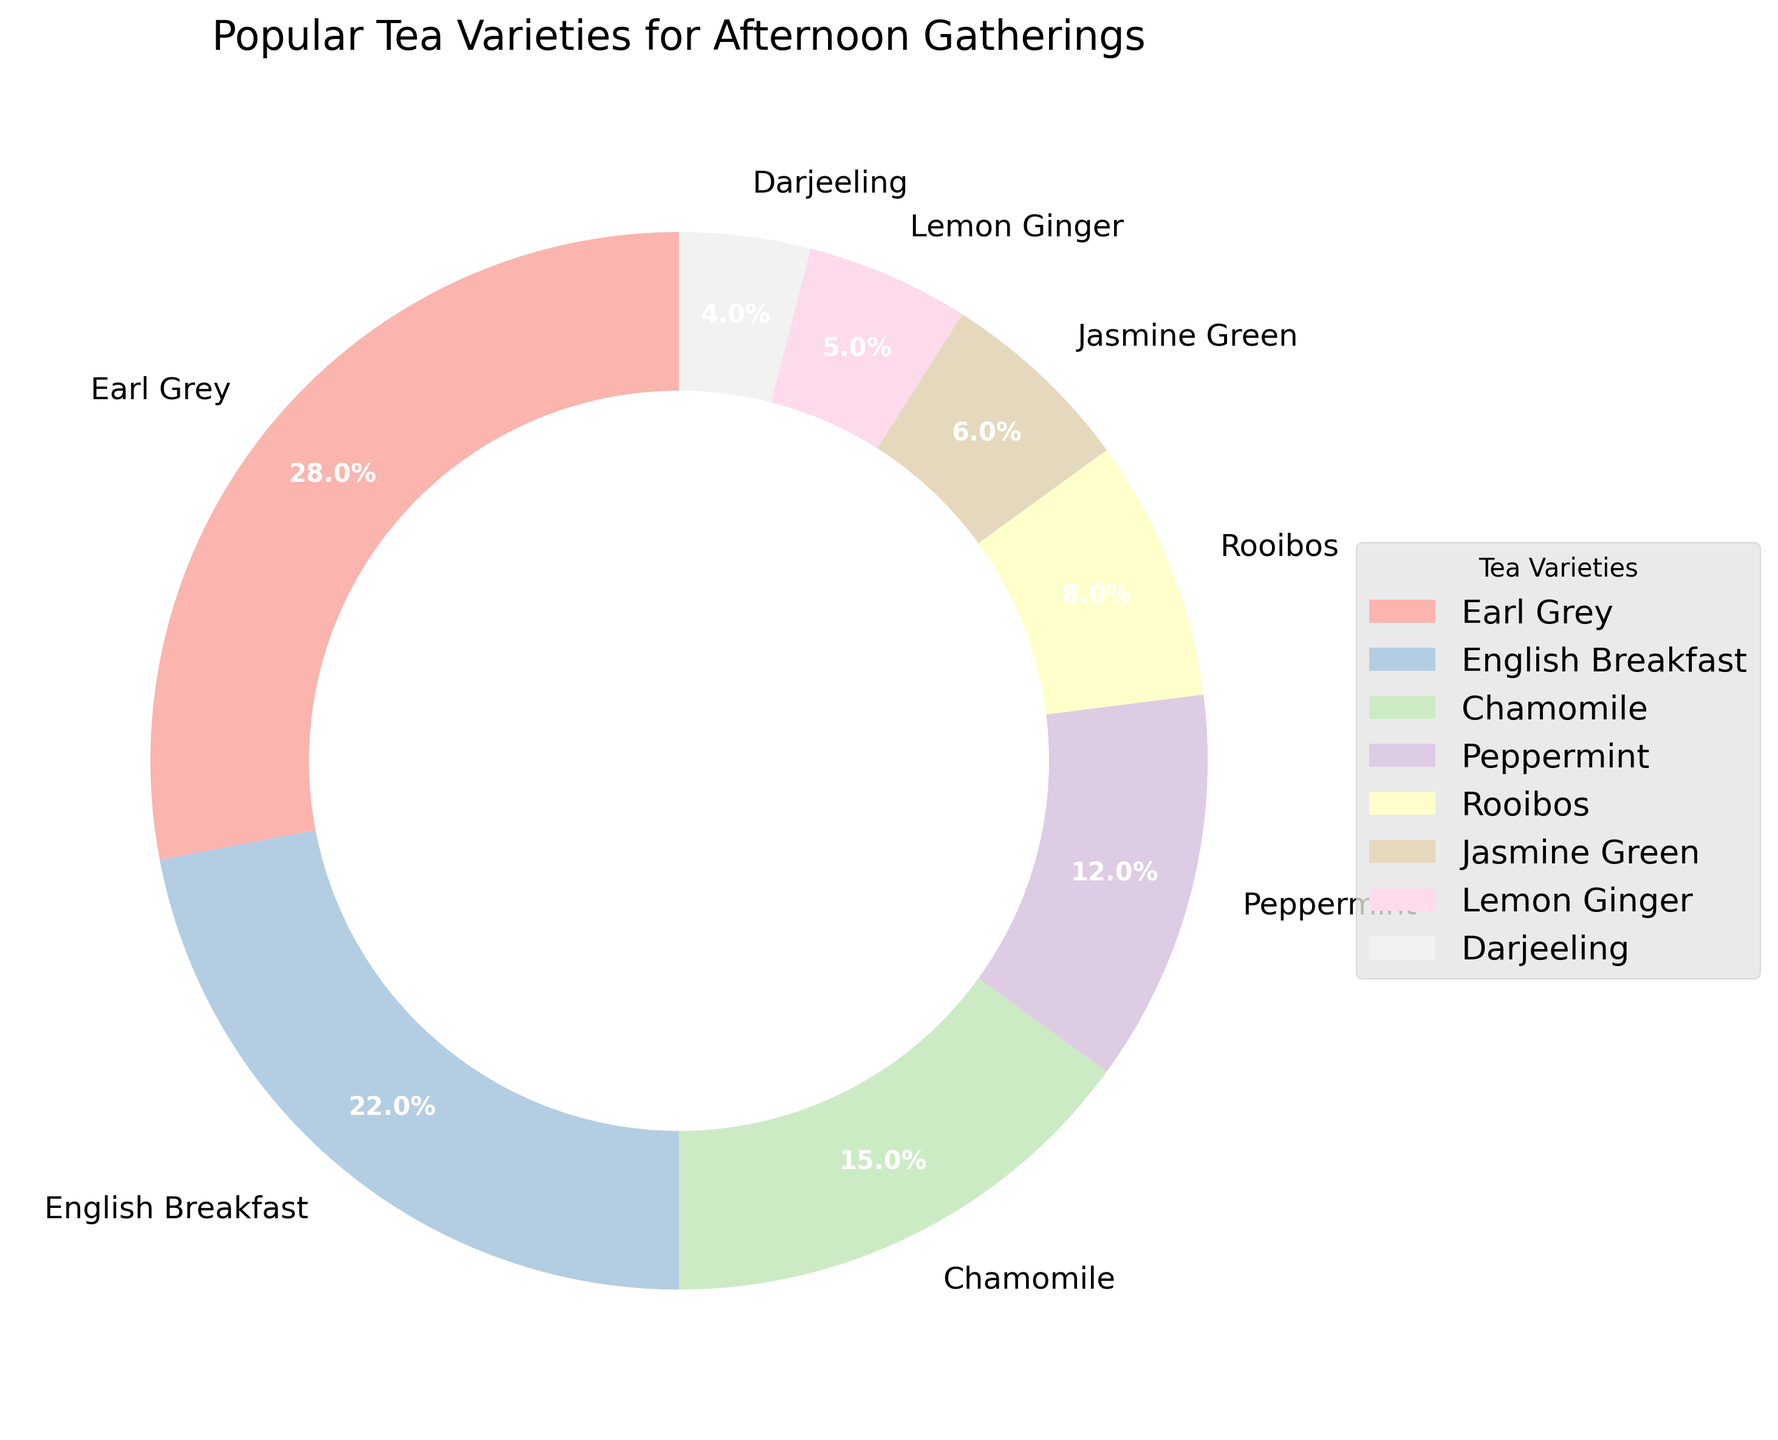What percentage of afternoon tea gatherings prefer Earl Grey over Peppermint? Earl Grey is at 28% and Peppermint is at 12%. The difference between them is 28 - 12 = 16%
Answer: 16% Which tea variety is the least popular during afternoon gatherings? The pie chart shows that Darjeeling has the smallest segment, representing the least percentage of 4% among all varieties.
Answer: Darjeeling Which tea varieties together make up more than half of the total consumption? Adding percentages: Earl Grey (28%) + English Breakfast (22%) = 50%, which is exactly half. Adding any more tea varieties will make it exceed half. Therefore, Earl Grey and English Breakfast together make up half the total consumption.
Answer: Earl Grey and English Breakfast Compare the popularity of Chamomile to Rooibos. Which is more popular and by how much? Chamomile is at 15% and Rooibos is at 8%. The difference between them is 15 - 8 = 7%. Chamomile is more popular by 7%.
Answer: Chamomile, by 7% If we combine the least three popular tea varieties, what is their combined percentage? The least three popular varieties are Darjeeling (4%), Lemon Ginger (5%), and Jasmine Green (6%). Their combined percentage is 4 + 5 + 6 = 15%.
Answer: 15% What percentage of gatherings prefer flavored teas (Chamomile, Lemon Ginger, Peppermint)? Chamomile (15%) + Lemon Ginger (5%) + Peppermint (12%) = 32%.
Answer: 32% Which two tea varieties would form exactly one-third of the total consumption? Looking for pairs of tea varieties: Rooibos (8%) + Jasmine Green (6%) = 14%, Chamomile (15%) + Lemon Ginger (5%) = 20%, Chamomile (15%) + Peppermint (12%) = 27%, Darjeeling (4%) + Jasmine Green (6%) = 10%. None of these sum up to one-third (33.33%). Earl Grey (28%) + any other single variety also exceeds one-third, so there is no pair that forms exactly one-third.
Answer: None Which tea variety holds exactly double the percentage of Rooibos? Rooibos is 8%, so we look for a variety that is 16%. However, none of the varieties listed show a 16% share, thus there's no such tea variety.
Answer: None 